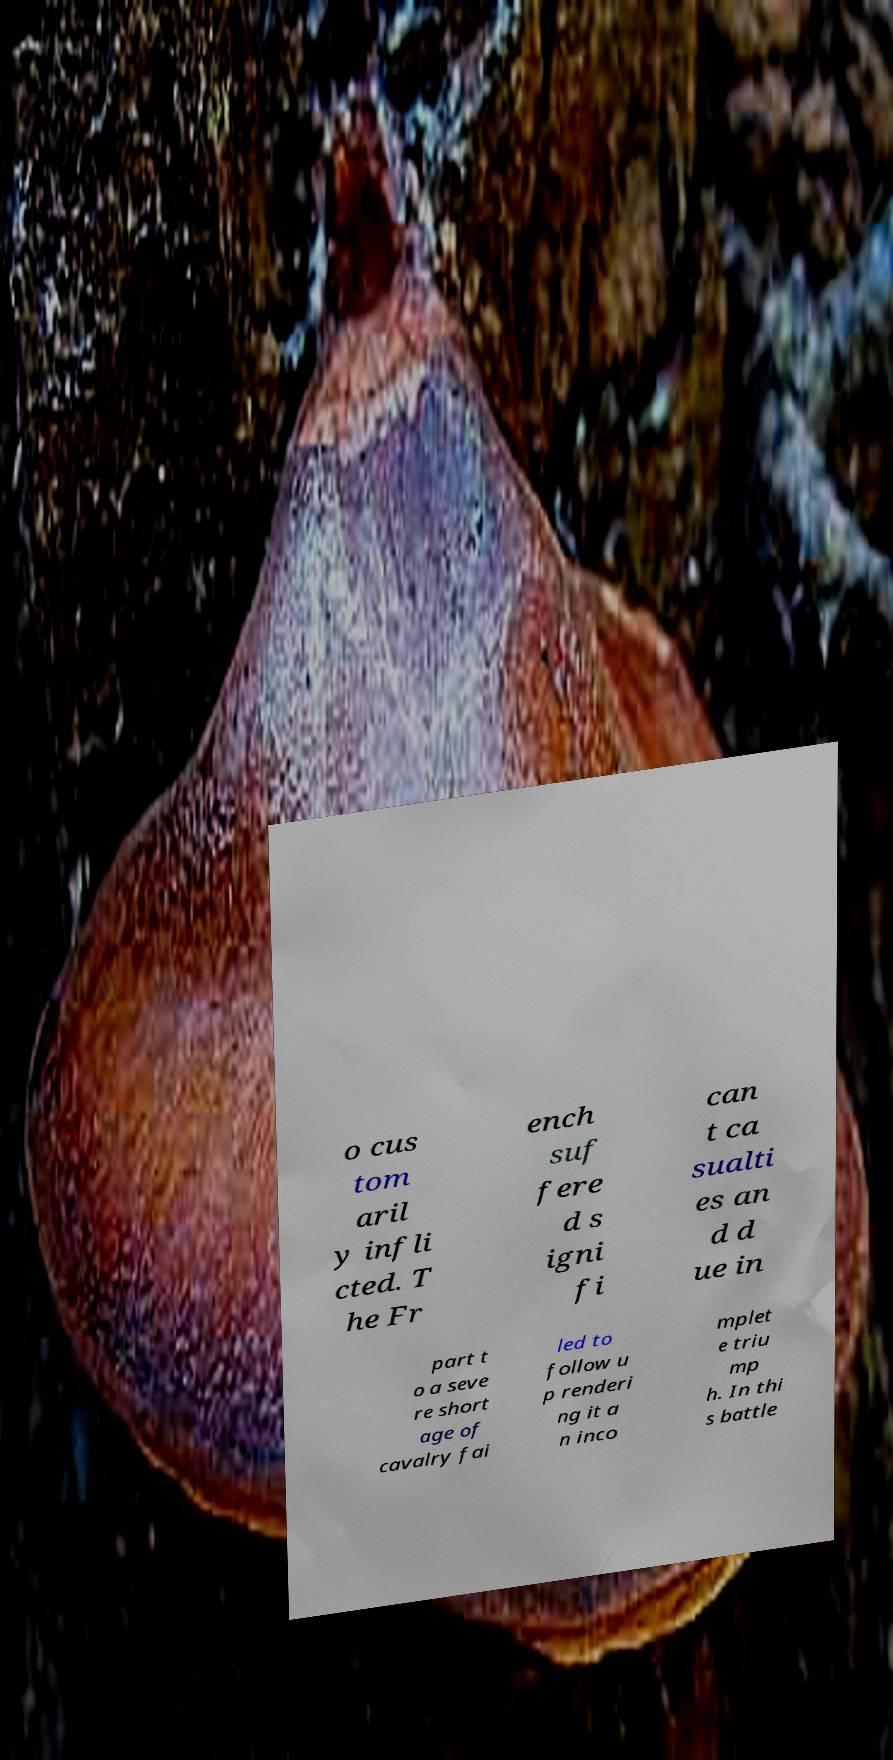Can you read and provide the text displayed in the image?This photo seems to have some interesting text. Can you extract and type it out for me? o cus tom aril y infli cted. T he Fr ench suf fere d s igni fi can t ca sualti es an d d ue in part t o a seve re short age of cavalry fai led to follow u p renderi ng it a n inco mplet e triu mp h. In thi s battle 